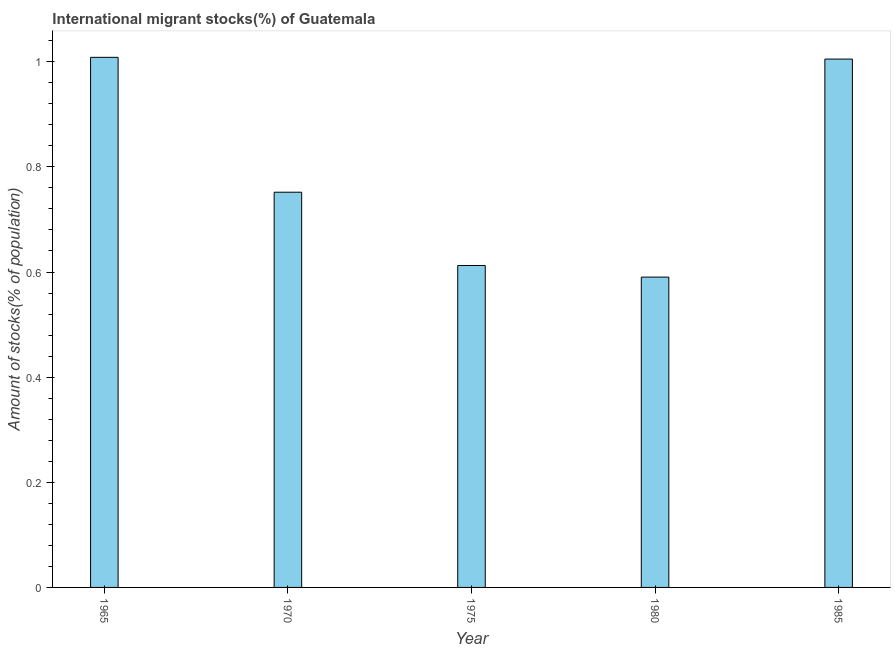What is the title of the graph?
Provide a succinct answer. International migrant stocks(%) of Guatemala. What is the label or title of the Y-axis?
Ensure brevity in your answer.  Amount of stocks(% of population). What is the number of international migrant stocks in 1970?
Your response must be concise. 0.75. Across all years, what is the maximum number of international migrant stocks?
Keep it short and to the point. 1.01. Across all years, what is the minimum number of international migrant stocks?
Offer a very short reply. 0.59. In which year was the number of international migrant stocks maximum?
Offer a very short reply. 1965. What is the sum of the number of international migrant stocks?
Offer a terse response. 3.97. What is the difference between the number of international migrant stocks in 1980 and 1985?
Offer a terse response. -0.41. What is the average number of international migrant stocks per year?
Your response must be concise. 0.79. What is the median number of international migrant stocks?
Keep it short and to the point. 0.75. In how many years, is the number of international migrant stocks greater than 0.28 %?
Keep it short and to the point. 5. Do a majority of the years between 1985 and 1980 (inclusive) have number of international migrant stocks greater than 0.72 %?
Offer a terse response. No. What is the ratio of the number of international migrant stocks in 1975 to that in 1985?
Give a very brief answer. 0.61. What is the difference between the highest and the second highest number of international migrant stocks?
Offer a very short reply. 0. What is the difference between the highest and the lowest number of international migrant stocks?
Keep it short and to the point. 0.42. In how many years, is the number of international migrant stocks greater than the average number of international migrant stocks taken over all years?
Your response must be concise. 2. Are all the bars in the graph horizontal?
Give a very brief answer. No. Are the values on the major ticks of Y-axis written in scientific E-notation?
Offer a very short reply. No. What is the Amount of stocks(% of population) of 1965?
Your answer should be compact. 1.01. What is the Amount of stocks(% of population) in 1970?
Provide a short and direct response. 0.75. What is the Amount of stocks(% of population) of 1975?
Ensure brevity in your answer.  0.61. What is the Amount of stocks(% of population) of 1980?
Your answer should be very brief. 0.59. What is the Amount of stocks(% of population) in 1985?
Provide a succinct answer. 1.01. What is the difference between the Amount of stocks(% of population) in 1965 and 1970?
Your response must be concise. 0.26. What is the difference between the Amount of stocks(% of population) in 1965 and 1975?
Offer a terse response. 0.4. What is the difference between the Amount of stocks(% of population) in 1965 and 1980?
Offer a very short reply. 0.42. What is the difference between the Amount of stocks(% of population) in 1965 and 1985?
Offer a terse response. 0. What is the difference between the Amount of stocks(% of population) in 1970 and 1975?
Your answer should be compact. 0.14. What is the difference between the Amount of stocks(% of population) in 1970 and 1980?
Ensure brevity in your answer.  0.16. What is the difference between the Amount of stocks(% of population) in 1970 and 1985?
Your answer should be very brief. -0.25. What is the difference between the Amount of stocks(% of population) in 1975 and 1980?
Offer a very short reply. 0.02. What is the difference between the Amount of stocks(% of population) in 1975 and 1985?
Offer a very short reply. -0.39. What is the difference between the Amount of stocks(% of population) in 1980 and 1985?
Your answer should be very brief. -0.41. What is the ratio of the Amount of stocks(% of population) in 1965 to that in 1970?
Offer a terse response. 1.34. What is the ratio of the Amount of stocks(% of population) in 1965 to that in 1975?
Give a very brief answer. 1.65. What is the ratio of the Amount of stocks(% of population) in 1965 to that in 1980?
Ensure brevity in your answer.  1.71. What is the ratio of the Amount of stocks(% of population) in 1965 to that in 1985?
Your answer should be compact. 1. What is the ratio of the Amount of stocks(% of population) in 1970 to that in 1975?
Your response must be concise. 1.23. What is the ratio of the Amount of stocks(% of population) in 1970 to that in 1980?
Your response must be concise. 1.27. What is the ratio of the Amount of stocks(% of population) in 1970 to that in 1985?
Your response must be concise. 0.75. What is the ratio of the Amount of stocks(% of population) in 1975 to that in 1980?
Offer a very short reply. 1.04. What is the ratio of the Amount of stocks(% of population) in 1975 to that in 1985?
Your answer should be very brief. 0.61. What is the ratio of the Amount of stocks(% of population) in 1980 to that in 1985?
Your answer should be very brief. 0.59. 